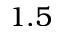Convert formula to latex. <formula><loc_0><loc_0><loc_500><loc_500>1 . 5</formula> 